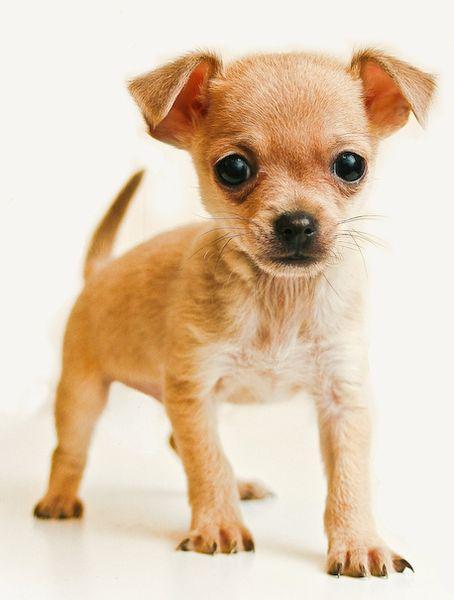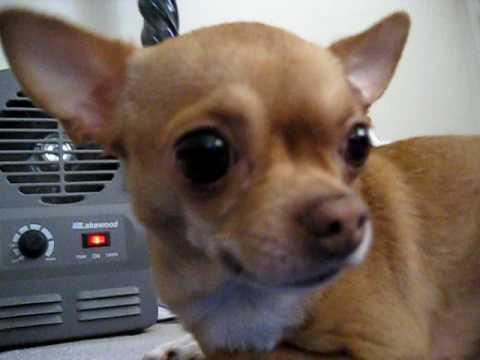The first image is the image on the left, the second image is the image on the right. Evaluate the accuracy of this statement regarding the images: "In at least one image, the dog's teeth are not bared.". Is it true? Answer yes or no. Yes. 